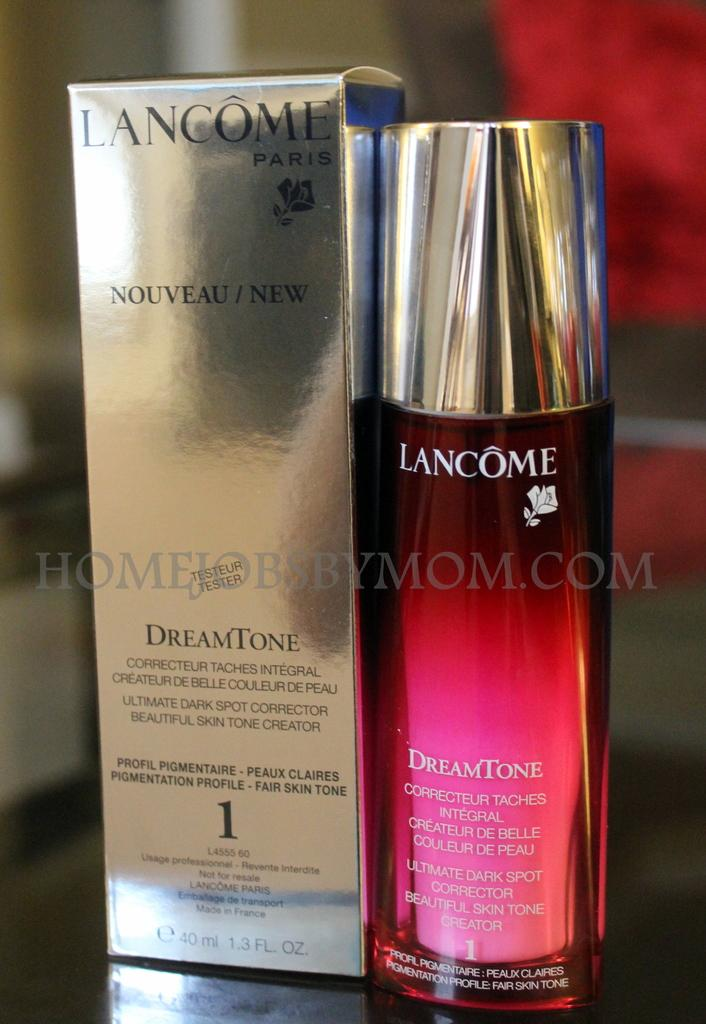<image>
Offer a succinct explanation of the picture presented. Red Lancome bottle next to a Dreamtone bottle. 